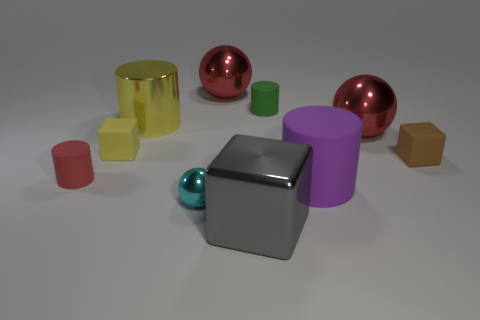Are there any blocks behind the large purple cylinder?
Your answer should be very brief. Yes. What is the shape of the red matte object?
Provide a short and direct response. Cylinder. What is the shape of the small rubber object that is right of the large red object that is on the right side of the large cylinder in front of the brown cube?
Your response must be concise. Cube. What number of other objects are there of the same shape as the big purple matte thing?
Offer a terse response. 3. There is a large cylinder on the right side of the big shiny thing in front of the cyan shiny sphere; what is it made of?
Offer a very short reply. Rubber. Is the material of the green object the same as the block that is to the right of the gray object?
Ensure brevity in your answer.  Yes. There is a big object that is left of the purple cylinder and in front of the small red cylinder; what material is it made of?
Give a very brief answer. Metal. What is the color of the big cylinder right of the red shiny sphere that is on the left side of the big block?
Ensure brevity in your answer.  Purple. What is the material of the small block that is on the right side of the tiny green matte thing?
Provide a short and direct response. Rubber. Are there fewer small blue shiny things than tiny green rubber cylinders?
Your answer should be compact. Yes. 